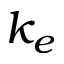Convert formula to latex. <formula><loc_0><loc_0><loc_500><loc_500>k _ { e }</formula> 